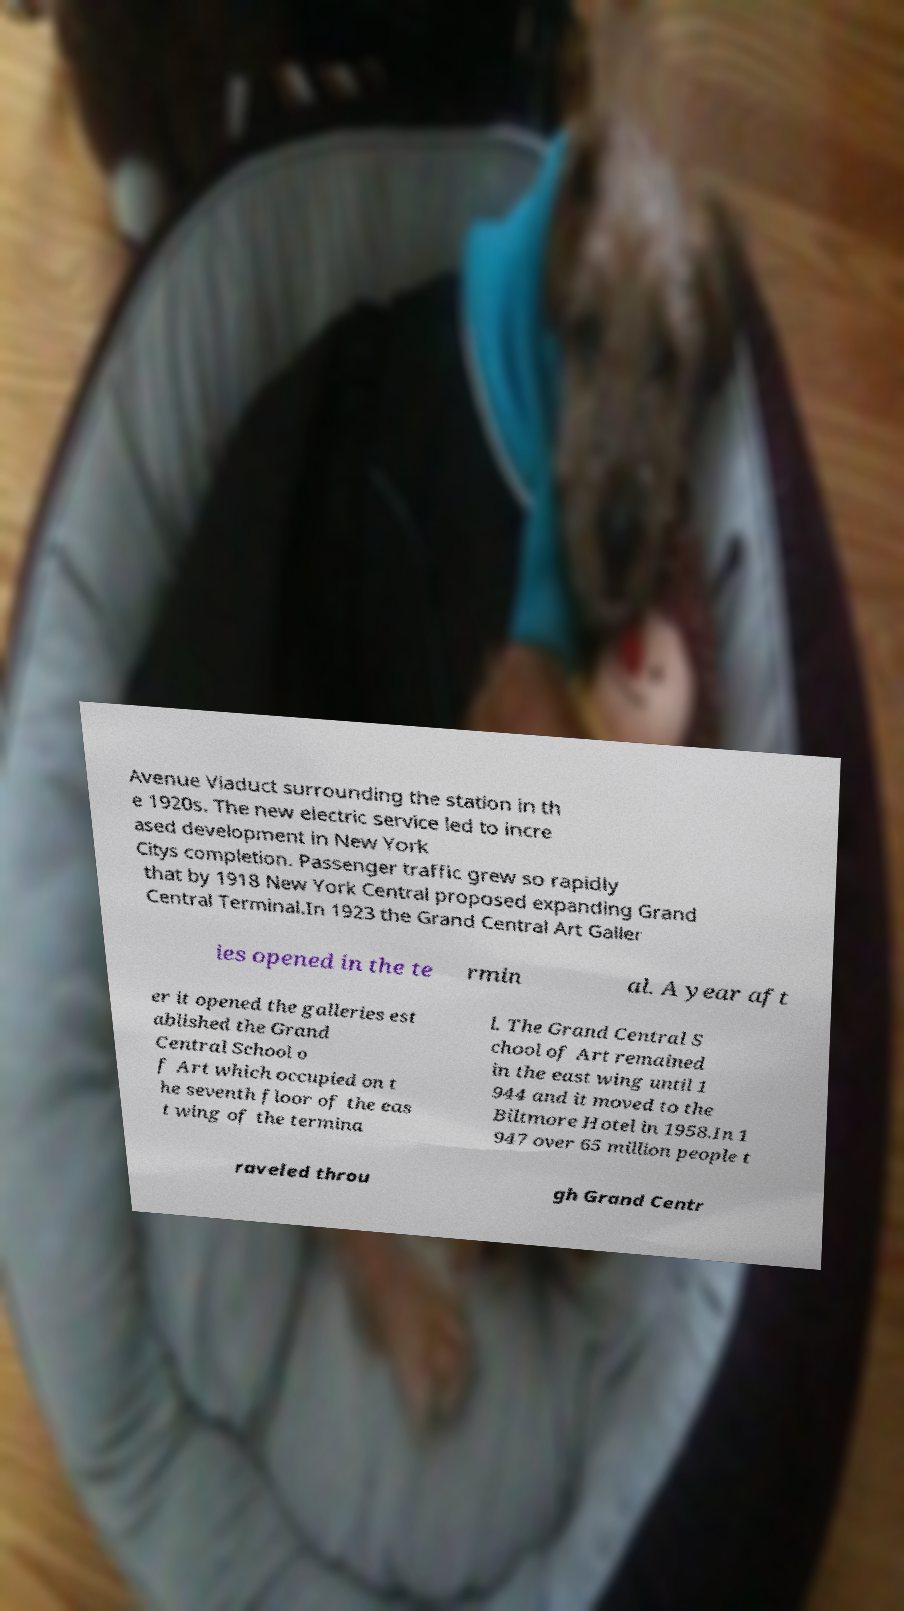Please read and relay the text visible in this image. What does it say? Avenue Viaduct surrounding the station in th e 1920s. The new electric service led to incre ased development in New York Citys completion. Passenger traffic grew so rapidly that by 1918 New York Central proposed expanding Grand Central Terminal.In 1923 the Grand Central Art Galler ies opened in the te rmin al. A year aft er it opened the galleries est ablished the Grand Central School o f Art which occupied on t he seventh floor of the eas t wing of the termina l. The Grand Central S chool of Art remained in the east wing until 1 944 and it moved to the Biltmore Hotel in 1958.In 1 947 over 65 million people t raveled throu gh Grand Centr 